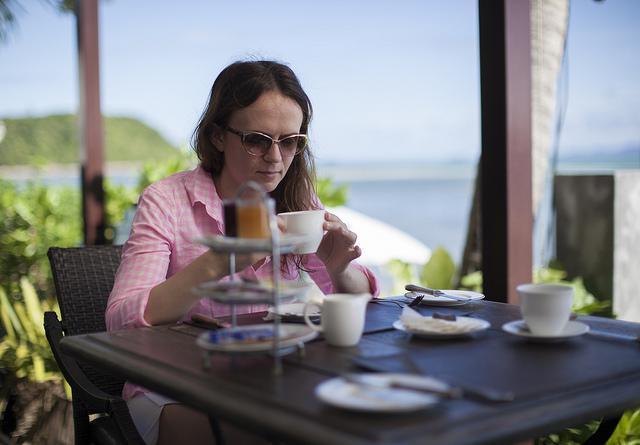How many cups are there?
Give a very brief answer. 2. How many people are there?
Give a very brief answer. 1. 